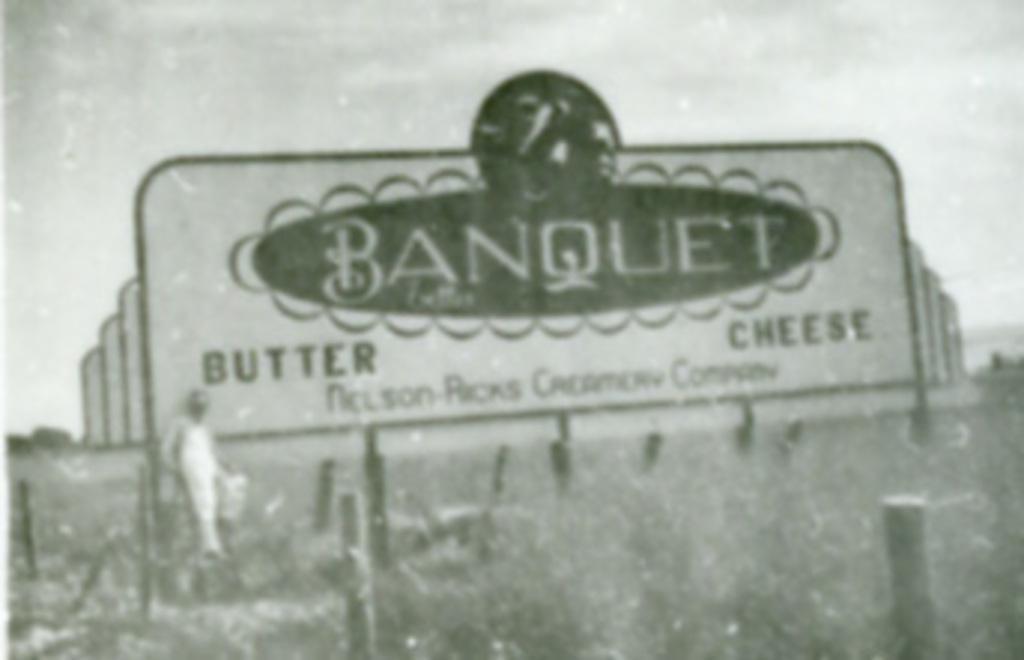Please provide a concise description of this image. This picture is blur, we can see hoarding, person and poles. In the background we can see sky. 